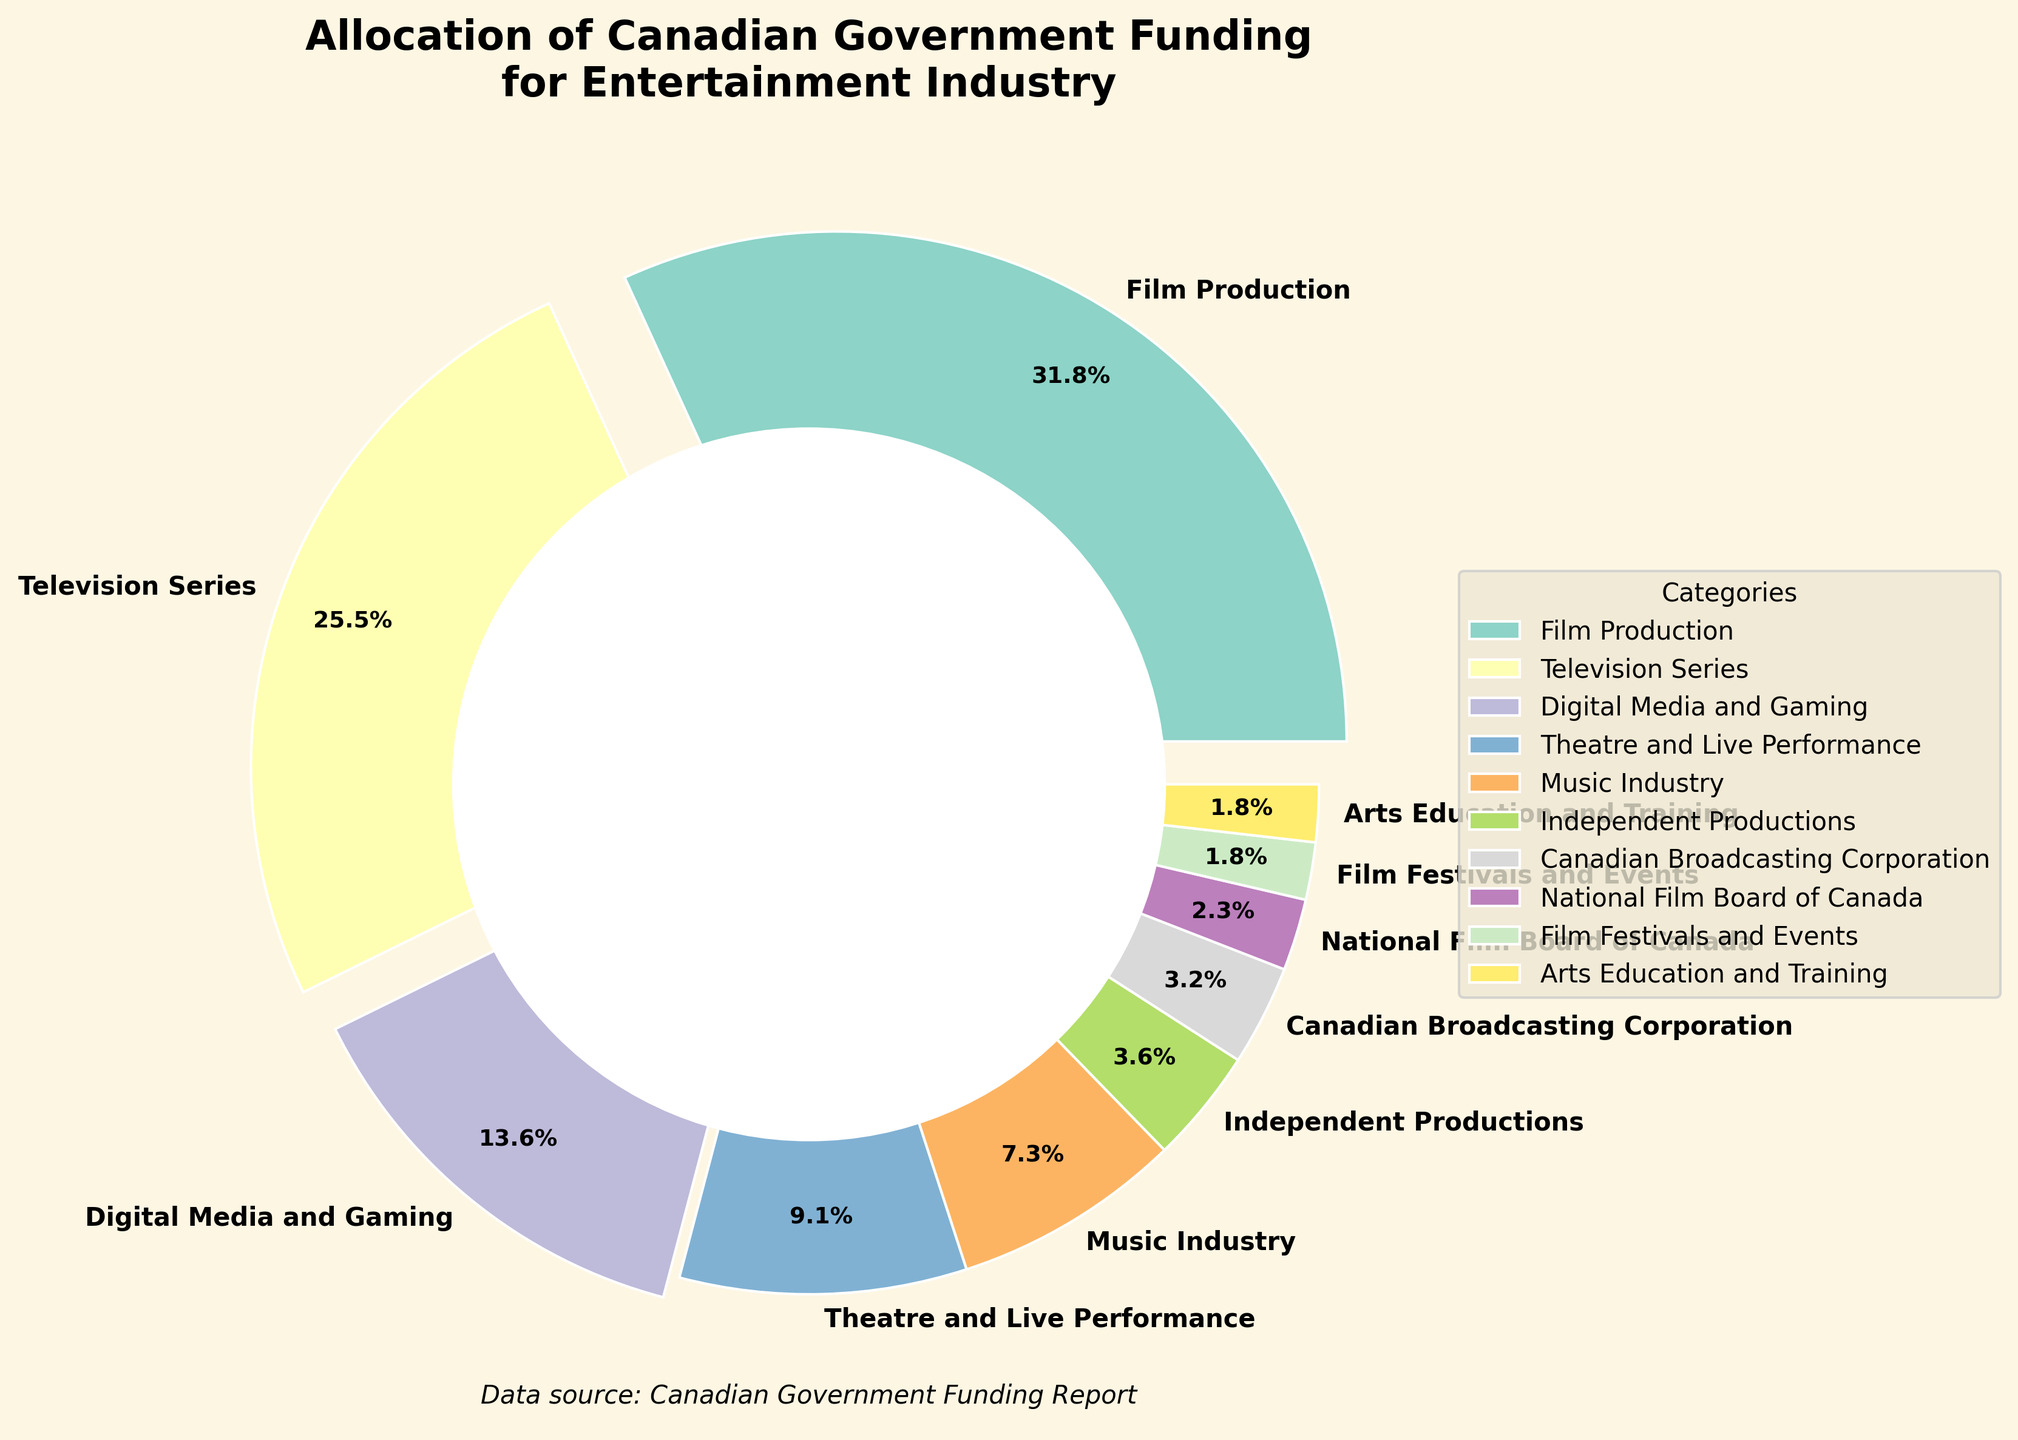What percentage of the funding is allocated to Film Production and Television Series combined? Sum the allocations for Film Production (35%) and Television Series (28%): 35 + 28 = 63
Answer: 63% How does the allocation for Film Production compare to Digital Media and Gaming? Film Production has an allocation of 35%, while Digital Media and Gaming is allocated 15%. So, Film Production receives a higher allocation by 20 percentage points, i.e., 35 - 15 = 20
Answer: 20 percentage points higher Which category receives the least funding and what is it? The category with the smallest allocation is Arts Education and Training at 2%
Answer: Arts Education and Training with 2% Do Film Festivals and Events receive more or less funding than the Canadian Broadcasting Corporation? Film Festivals and Events (2%) receive less funding than the Canadian Broadcasting Corporation (3.5%)
Answer: Less What is the total percentage allocated to Independent Productions, Arts Education and Training, and Film Festivals and Events? Sum the allocations for Independent Productions (4%), Arts Education and Training (2%), and Film Festivals and Events (2%): 4 + 2 + 2 = 8
Answer: 8% Which categories have an allocation of less than 5%? Identify categories with less than 5% allocation: Independent Productions (4%), Canadian Broadcasting Corporation (3.5%), National Film Board of Canada (2.5%), Film Festivals and Events (2%), Arts Education and Training (2%)
Answer: Independent Productions, Canadian Broadcasting Corporation, National Film Board of Canada, Film Festivals and Events, Arts Education and Training What is the difference in allocation between Theatre and Live Performance and the Music Industry? Theatre and Live Performance is allocated 10%, while the Music Industry is allocated 8%. The difference is 10 - 8 = 2
Answer: 2% Which category occupies the largest wedge in the pie chart and by how much? The largest wedge in the pie chart is Film Production at 35%
Answer: Film Production with 35% How much more funding is allocated to Television Series compared to Theatre and Live Performance? Television Series is allocated 28%, while Theatre and Live Performance is allocated 10%. The difference is 28 - 10 = 18
Answer: 18% What is the average percentage allocation for the categories that receive 10% or greater funding (Film Production, Television Series, Theatre and Live Performance)? Sum the allocations of these categories: Film Production (35%), Television Series (28%), Theatre and Live Performance (10%): 35 + 28 + 10 = 73. The average is 73 / 3 = 24.33
Answer: 24.33 